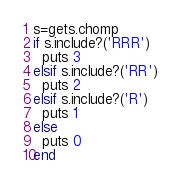Convert code to text. <code><loc_0><loc_0><loc_500><loc_500><_Ruby_>s=gets.chomp
if s.include?('RRR')
  puts 3
elsif s.include?('RR')
  puts 2
elsif s.include?('R')
  puts 1
else
  puts 0
end</code> 